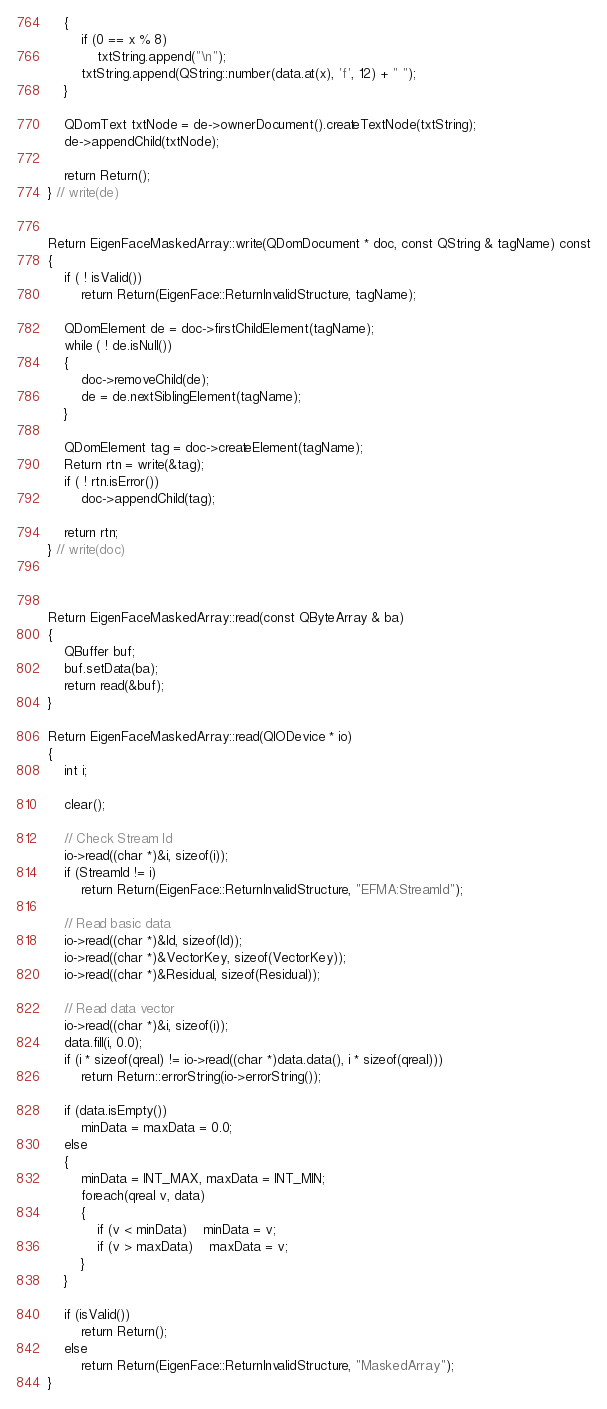Convert code to text. <code><loc_0><loc_0><loc_500><loc_500><_C++_>	{
		if (0 == x % 8)
			txtString.append("\n");
		txtString.append(QString::number(data.at(x), 'f', 12) + " ");
	}

	QDomText txtNode = de->ownerDocument().createTextNode(txtString);
	de->appendChild(txtNode);

	return Return();
} // write(de)

		
Return EigenFaceMaskedArray::write(QDomDocument * doc, const QString & tagName) const
{
	if ( ! isValid())
		return Return(EigenFace::ReturnInvalidStructure, tagName);

	QDomElement de = doc->firstChildElement(tagName);
	while ( ! de.isNull())
	{
		doc->removeChild(de);
		de = de.nextSiblingElement(tagName);
	}

	QDomElement tag = doc->createElement(tagName);
	Return rtn = write(&tag);
	if ( ! rtn.isError())
		doc->appendChild(tag);

	return rtn;
} // write(doc)

	

Return EigenFaceMaskedArray::read(const QByteArray & ba)
{
	QBuffer buf;
	buf.setData(ba);
	return read(&buf);
}

Return EigenFaceMaskedArray::read(QIODevice * io)
{
	int i;

	clear();

	// Check Stream Id
	io->read((char *)&i, sizeof(i));
	if (StreamId != i)
		return Return(EigenFace::ReturnInvalidStructure, "EFMA:StreamId");

	// Read basic data
	io->read((char *)&Id, sizeof(Id));
	io->read((char *)&VectorKey, sizeof(VectorKey));
	io->read((char *)&Residual, sizeof(Residual));

	// Read data vector
	io->read((char *)&i, sizeof(i));
	data.fill(i, 0.0);
	if (i * sizeof(qreal) != io->read((char *)data.data(), i * sizeof(qreal)))
		return Return::errorString(io->errorString());

	if (data.isEmpty())
		minData = maxData = 0.0;
	else
	{
		minData = INT_MAX, maxData = INT_MIN;
		foreach(qreal v, data)
		{
			if (v < minData)	minData = v;
			if (v > maxData)	maxData = v;
		}
	}

	if (isValid())
		return Return();
	else
		return Return(EigenFace::ReturnInvalidStructure, "MaskedArray");
}

</code> 